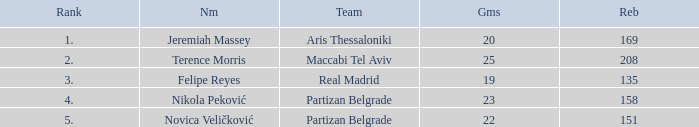What is the number of Games for Partizan Belgrade player Nikola Peković with a Rank of more than 4? None. 